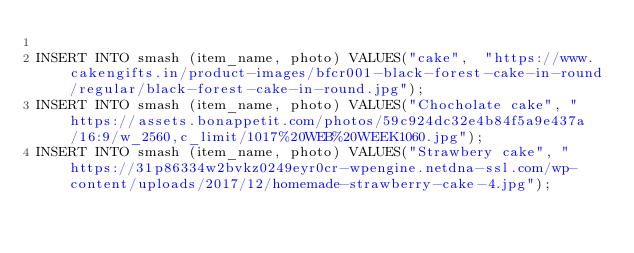Convert code to text. <code><loc_0><loc_0><loc_500><loc_500><_SQL_>
INSERT INTO	smash (item_name, photo) VALUES("cake",  "https://www.cakengifts.in/product-images/bfcr001-black-forest-cake-in-round/regular/black-forest-cake-in-round.jpg");
INSERT INTO	smash (item_name, photo) VALUES("Chocholate cake", "https://assets.bonappetit.com/photos/59c924dc32e4b84f5a9e437a/16:9/w_2560,c_limit/1017%20WEB%20WEEK1060.jpg");
INSERT INTO	smash (item_name, photo) VALUES("Strawbery cake", "https://31p86334w2bvkz0249eyr0cr-wpengine.netdna-ssl.com/wp-content/uploads/2017/12/homemade-strawberry-cake-4.jpg");</code> 